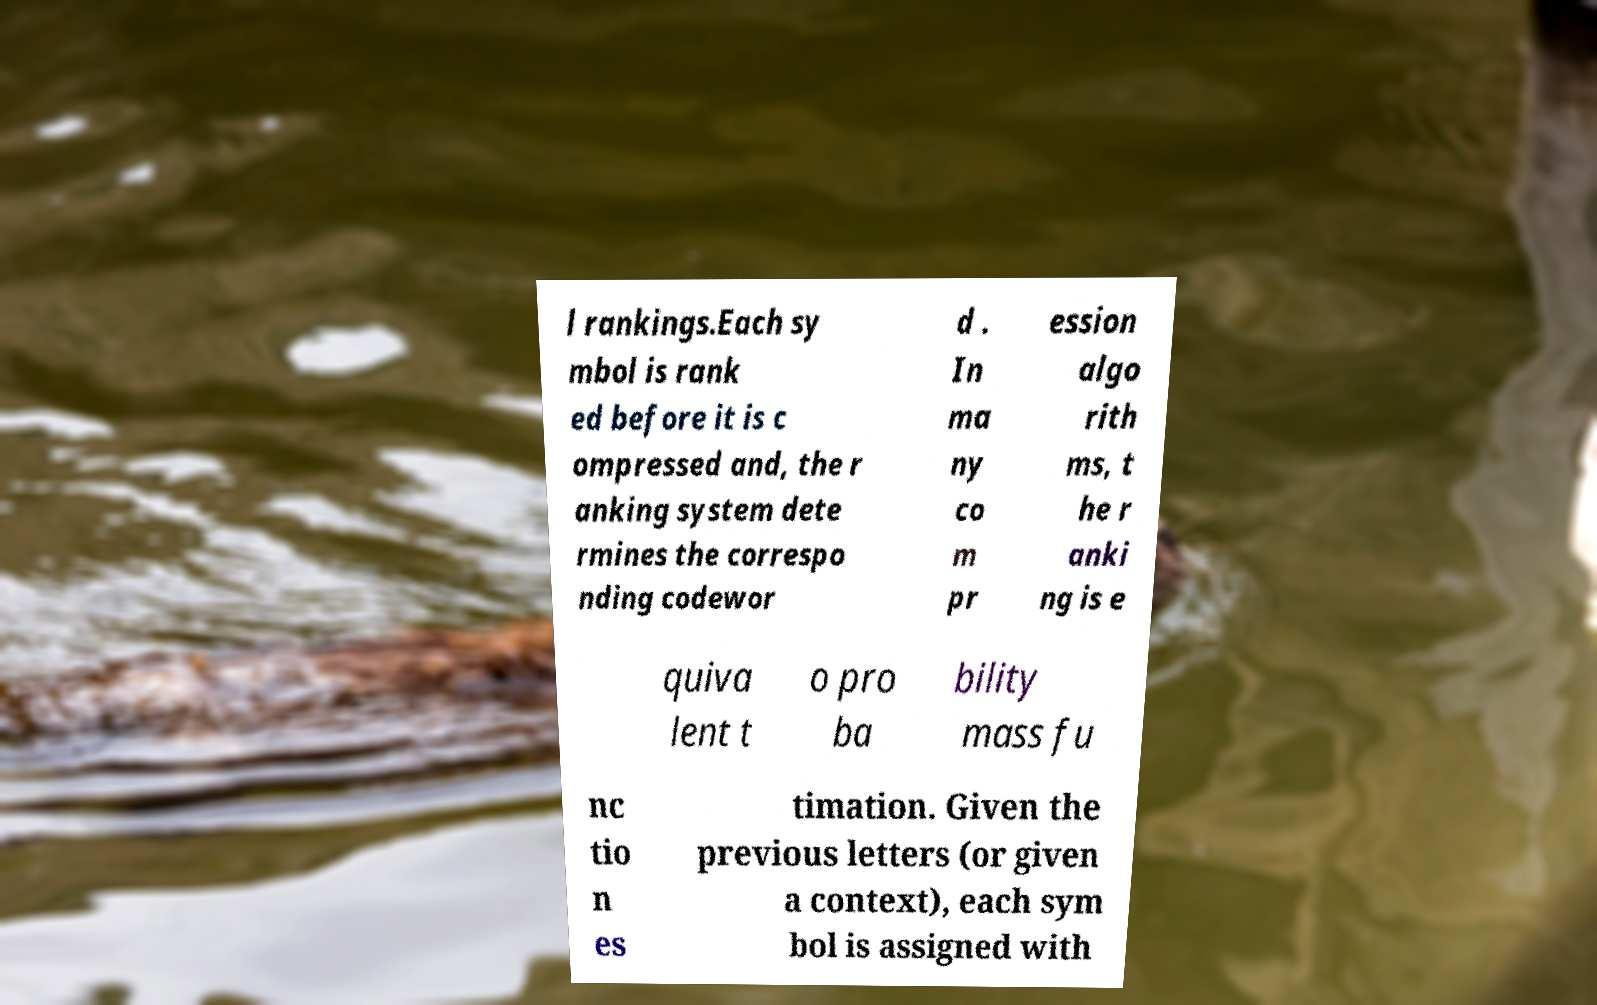Please identify and transcribe the text found in this image. l rankings.Each sy mbol is rank ed before it is c ompressed and, the r anking system dete rmines the correspo nding codewor d . In ma ny co m pr ession algo rith ms, t he r anki ng is e quiva lent t o pro ba bility mass fu nc tio n es timation. Given the previous letters (or given a context), each sym bol is assigned with 